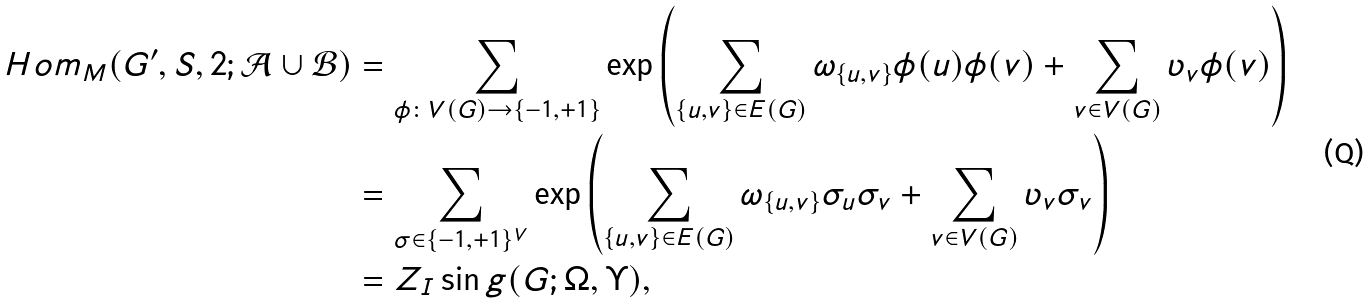<formula> <loc_0><loc_0><loc_500><loc_500>H o m _ { M } ( G ^ { \prime } , S , 2 ; \mathcal { A } \cup \mathcal { B } ) & = \sum _ { \phi \colon V ( G ) \to \{ - 1 , + 1 \} } \exp \left ( \sum _ { \{ u , v \} \in E ( G ) } \omega _ { \{ u , v \} } \phi ( u ) \phi ( v ) + \sum _ { v \in V ( G ) } \upsilon _ { v } \phi ( v ) \right ) \\ & = \sum _ { \sigma \in \{ - 1 , + 1 \} ^ { V } } \exp \left ( \sum _ { \{ u , v \} \in E ( G ) } \omega _ { \{ u , v \} } \sigma _ { u } \sigma _ { v } + \sum _ { v \in V ( G ) } \upsilon _ { v } \sigma _ { v } \right ) \\ & = Z _ { I } \sin g ( G ; \Omega , \Upsilon ) ,</formula> 